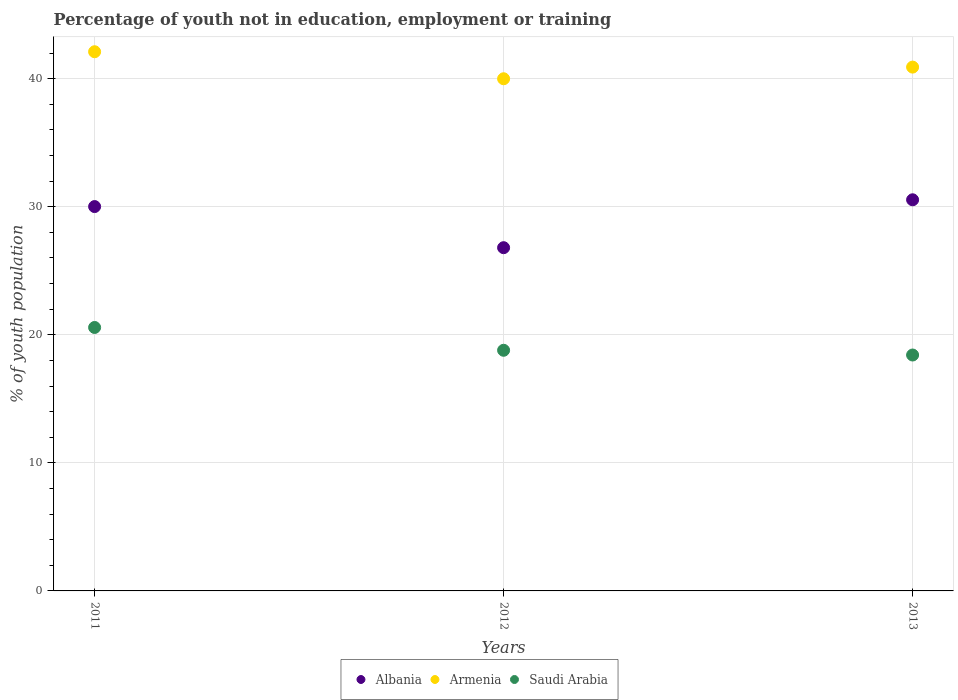How many different coloured dotlines are there?
Offer a terse response. 3. What is the percentage of unemployed youth population in in Saudi Arabia in 2012?
Provide a short and direct response. 18.79. Across all years, what is the maximum percentage of unemployed youth population in in Armenia?
Keep it short and to the point. 42.1. Across all years, what is the minimum percentage of unemployed youth population in in Saudi Arabia?
Make the answer very short. 18.42. What is the total percentage of unemployed youth population in in Albania in the graph?
Give a very brief answer. 87.35. What is the difference between the percentage of unemployed youth population in in Armenia in 2012 and that in 2013?
Offer a very short reply. -0.91. What is the difference between the percentage of unemployed youth population in in Armenia in 2011 and the percentage of unemployed youth population in in Saudi Arabia in 2012?
Your answer should be very brief. 23.31. What is the average percentage of unemployed youth population in in Armenia per year?
Your answer should be compact. 41. In the year 2012, what is the difference between the percentage of unemployed youth population in in Armenia and percentage of unemployed youth population in in Saudi Arabia?
Your response must be concise. 21.2. What is the ratio of the percentage of unemployed youth population in in Saudi Arabia in 2012 to that in 2013?
Provide a succinct answer. 1.02. Is the difference between the percentage of unemployed youth population in in Armenia in 2011 and 2013 greater than the difference between the percentage of unemployed youth population in in Saudi Arabia in 2011 and 2013?
Provide a succinct answer. No. What is the difference between the highest and the second highest percentage of unemployed youth population in in Albania?
Offer a terse response. 0.53. What is the difference between the highest and the lowest percentage of unemployed youth population in in Armenia?
Keep it short and to the point. 2.11. Is the sum of the percentage of unemployed youth population in in Armenia in 2012 and 2013 greater than the maximum percentage of unemployed youth population in in Albania across all years?
Offer a terse response. Yes. Does the percentage of unemployed youth population in in Armenia monotonically increase over the years?
Your answer should be compact. No. Is the percentage of unemployed youth population in in Armenia strictly greater than the percentage of unemployed youth population in in Albania over the years?
Your response must be concise. Yes. What is the difference between two consecutive major ticks on the Y-axis?
Make the answer very short. 10. Does the graph contain any zero values?
Ensure brevity in your answer.  No. Does the graph contain grids?
Your answer should be very brief. Yes. Where does the legend appear in the graph?
Your answer should be very brief. Bottom center. How many legend labels are there?
Give a very brief answer. 3. How are the legend labels stacked?
Your response must be concise. Horizontal. What is the title of the graph?
Offer a very short reply. Percentage of youth not in education, employment or training. What is the label or title of the Y-axis?
Your answer should be compact. % of youth population. What is the % of youth population in Albania in 2011?
Provide a short and direct response. 30.01. What is the % of youth population of Armenia in 2011?
Provide a short and direct response. 42.1. What is the % of youth population of Saudi Arabia in 2011?
Your answer should be compact. 20.57. What is the % of youth population in Albania in 2012?
Make the answer very short. 26.8. What is the % of youth population in Armenia in 2012?
Provide a short and direct response. 39.99. What is the % of youth population in Saudi Arabia in 2012?
Your response must be concise. 18.79. What is the % of youth population of Albania in 2013?
Make the answer very short. 30.54. What is the % of youth population of Armenia in 2013?
Your response must be concise. 40.9. What is the % of youth population in Saudi Arabia in 2013?
Your answer should be compact. 18.42. Across all years, what is the maximum % of youth population of Albania?
Offer a terse response. 30.54. Across all years, what is the maximum % of youth population of Armenia?
Ensure brevity in your answer.  42.1. Across all years, what is the maximum % of youth population of Saudi Arabia?
Provide a succinct answer. 20.57. Across all years, what is the minimum % of youth population of Albania?
Your answer should be very brief. 26.8. Across all years, what is the minimum % of youth population of Armenia?
Ensure brevity in your answer.  39.99. Across all years, what is the minimum % of youth population in Saudi Arabia?
Keep it short and to the point. 18.42. What is the total % of youth population of Albania in the graph?
Your response must be concise. 87.35. What is the total % of youth population in Armenia in the graph?
Give a very brief answer. 122.99. What is the total % of youth population in Saudi Arabia in the graph?
Keep it short and to the point. 57.78. What is the difference between the % of youth population in Albania in 2011 and that in 2012?
Make the answer very short. 3.21. What is the difference between the % of youth population in Armenia in 2011 and that in 2012?
Keep it short and to the point. 2.11. What is the difference between the % of youth population in Saudi Arabia in 2011 and that in 2012?
Keep it short and to the point. 1.78. What is the difference between the % of youth population of Albania in 2011 and that in 2013?
Your answer should be very brief. -0.53. What is the difference between the % of youth population of Armenia in 2011 and that in 2013?
Your answer should be very brief. 1.2. What is the difference between the % of youth population in Saudi Arabia in 2011 and that in 2013?
Your answer should be very brief. 2.15. What is the difference between the % of youth population of Albania in 2012 and that in 2013?
Provide a short and direct response. -3.74. What is the difference between the % of youth population of Armenia in 2012 and that in 2013?
Provide a succinct answer. -0.91. What is the difference between the % of youth population of Saudi Arabia in 2012 and that in 2013?
Offer a very short reply. 0.37. What is the difference between the % of youth population of Albania in 2011 and the % of youth population of Armenia in 2012?
Ensure brevity in your answer.  -9.98. What is the difference between the % of youth population of Albania in 2011 and the % of youth population of Saudi Arabia in 2012?
Provide a short and direct response. 11.22. What is the difference between the % of youth population of Armenia in 2011 and the % of youth population of Saudi Arabia in 2012?
Your response must be concise. 23.31. What is the difference between the % of youth population in Albania in 2011 and the % of youth population in Armenia in 2013?
Make the answer very short. -10.89. What is the difference between the % of youth population of Albania in 2011 and the % of youth population of Saudi Arabia in 2013?
Provide a succinct answer. 11.59. What is the difference between the % of youth population in Armenia in 2011 and the % of youth population in Saudi Arabia in 2013?
Offer a terse response. 23.68. What is the difference between the % of youth population in Albania in 2012 and the % of youth population in Armenia in 2013?
Your answer should be very brief. -14.1. What is the difference between the % of youth population of Albania in 2012 and the % of youth population of Saudi Arabia in 2013?
Give a very brief answer. 8.38. What is the difference between the % of youth population of Armenia in 2012 and the % of youth population of Saudi Arabia in 2013?
Your response must be concise. 21.57. What is the average % of youth population in Albania per year?
Provide a short and direct response. 29.12. What is the average % of youth population of Armenia per year?
Make the answer very short. 41. What is the average % of youth population in Saudi Arabia per year?
Your response must be concise. 19.26. In the year 2011, what is the difference between the % of youth population in Albania and % of youth population in Armenia?
Provide a short and direct response. -12.09. In the year 2011, what is the difference between the % of youth population in Albania and % of youth population in Saudi Arabia?
Offer a very short reply. 9.44. In the year 2011, what is the difference between the % of youth population of Armenia and % of youth population of Saudi Arabia?
Ensure brevity in your answer.  21.53. In the year 2012, what is the difference between the % of youth population of Albania and % of youth population of Armenia?
Give a very brief answer. -13.19. In the year 2012, what is the difference between the % of youth population of Albania and % of youth population of Saudi Arabia?
Your answer should be compact. 8.01. In the year 2012, what is the difference between the % of youth population in Armenia and % of youth population in Saudi Arabia?
Your response must be concise. 21.2. In the year 2013, what is the difference between the % of youth population in Albania and % of youth population in Armenia?
Keep it short and to the point. -10.36. In the year 2013, what is the difference between the % of youth population of Albania and % of youth population of Saudi Arabia?
Give a very brief answer. 12.12. In the year 2013, what is the difference between the % of youth population in Armenia and % of youth population in Saudi Arabia?
Provide a short and direct response. 22.48. What is the ratio of the % of youth population in Albania in 2011 to that in 2012?
Your answer should be compact. 1.12. What is the ratio of the % of youth population of Armenia in 2011 to that in 2012?
Offer a terse response. 1.05. What is the ratio of the % of youth population of Saudi Arabia in 2011 to that in 2012?
Your answer should be compact. 1.09. What is the ratio of the % of youth population of Albania in 2011 to that in 2013?
Your answer should be very brief. 0.98. What is the ratio of the % of youth population in Armenia in 2011 to that in 2013?
Ensure brevity in your answer.  1.03. What is the ratio of the % of youth population of Saudi Arabia in 2011 to that in 2013?
Offer a terse response. 1.12. What is the ratio of the % of youth population in Albania in 2012 to that in 2013?
Keep it short and to the point. 0.88. What is the ratio of the % of youth population of Armenia in 2012 to that in 2013?
Your answer should be very brief. 0.98. What is the ratio of the % of youth population of Saudi Arabia in 2012 to that in 2013?
Give a very brief answer. 1.02. What is the difference between the highest and the second highest % of youth population in Albania?
Your answer should be very brief. 0.53. What is the difference between the highest and the second highest % of youth population of Armenia?
Offer a very short reply. 1.2. What is the difference between the highest and the second highest % of youth population in Saudi Arabia?
Give a very brief answer. 1.78. What is the difference between the highest and the lowest % of youth population of Albania?
Keep it short and to the point. 3.74. What is the difference between the highest and the lowest % of youth population of Armenia?
Provide a succinct answer. 2.11. What is the difference between the highest and the lowest % of youth population of Saudi Arabia?
Your answer should be compact. 2.15. 